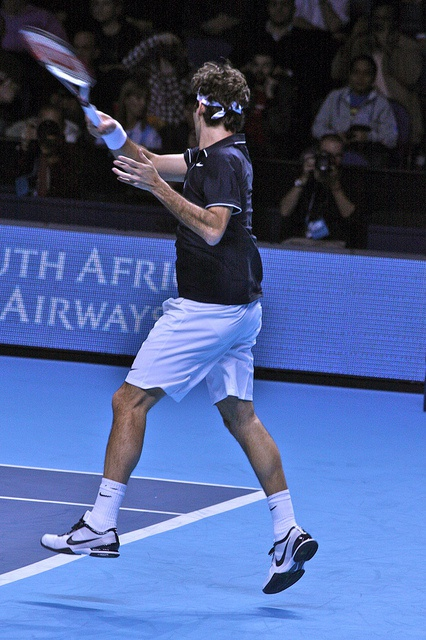Describe the objects in this image and their specific colors. I can see people in black, lightblue, and gray tones, people in black, purple, and gray tones, people in black and purple tones, people in black, navy, and gray tones, and people in black and purple tones in this image. 